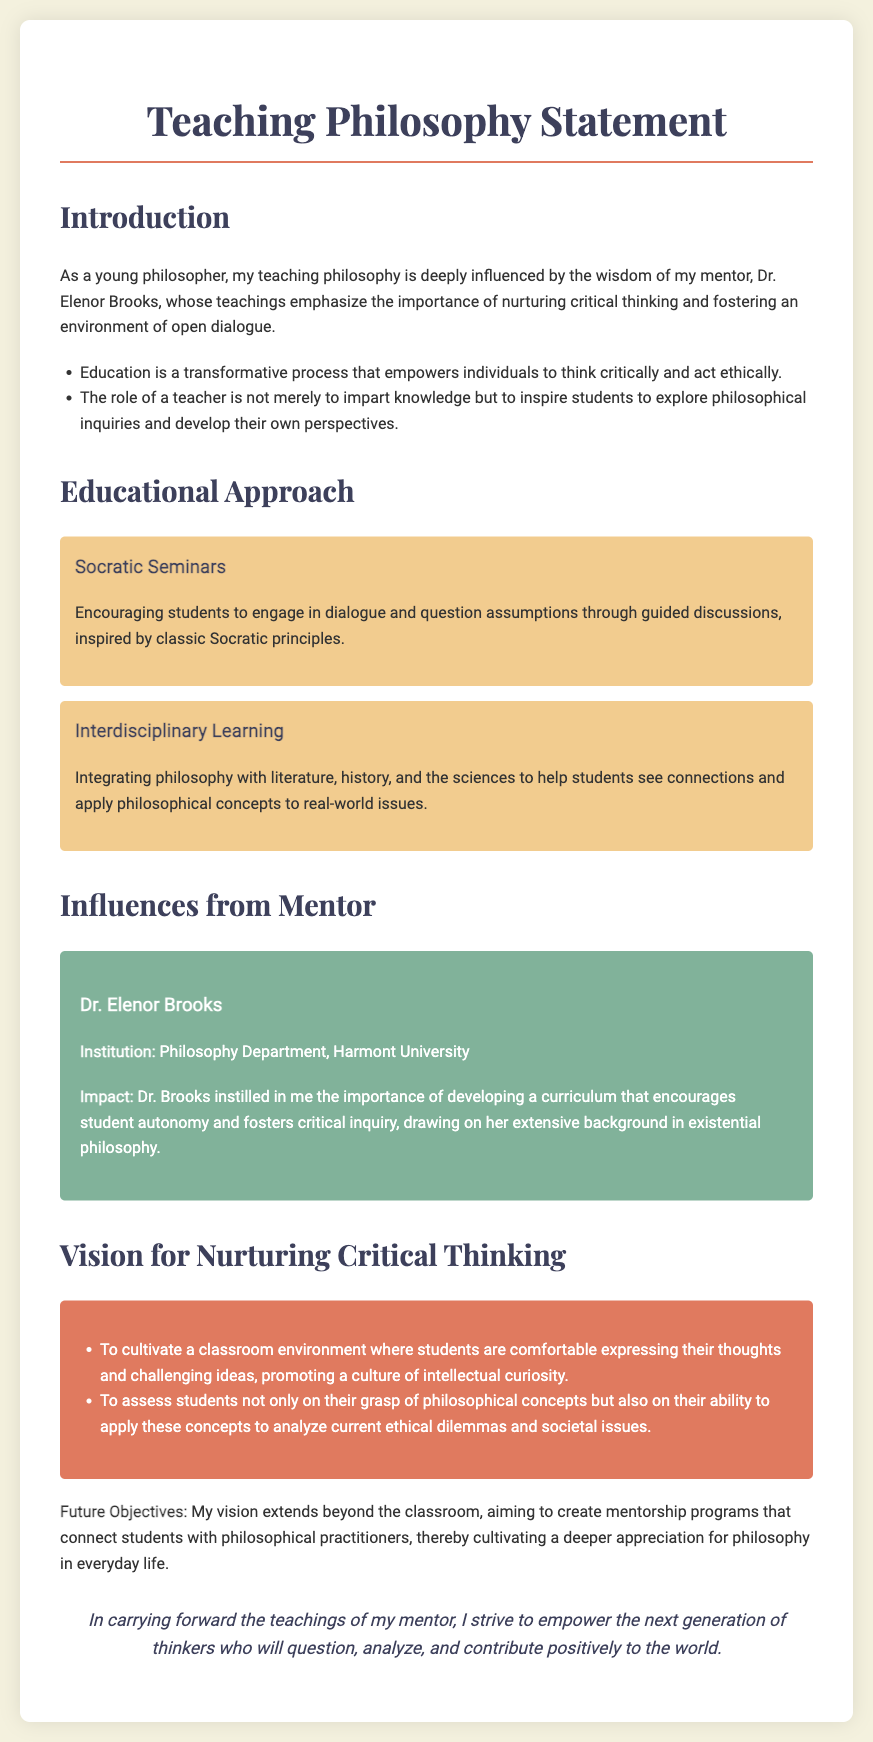What is the name of the mentor mentioned? The mentor mentioned is a significant influence in the teaching philosophy. The document states her name clearly as "Dr. Elenor Brooks."
Answer: Dr. Elenor Brooks What is the institution where the mentor teaches? The document specifies the mentor's affiliation, indicating her institutional background.
Answer: Harmont University What educational approach is highlighted first in the document? The first method of teaching outlined in the document is about a classical technique often used for discussion-based learning.
Answer: Socratic Seminars What are the two areas integrated into the educational approach besides philosophy? The document explains an interdisciplinary approach that connects philosophy with other fields, specifying two.
Answer: Literature and history What key concept does the teaching philosophy emphasize regarding students' expression? The document highlights the importance of creating an environment where students can share their thoughts freely.
Answer: Intellectual curiosity How does the teaching philosophy propose to assess students? The assessment approach outlined in the document goes beyond just knowledge retention to a more practical application of learned concepts.
Answer: Analyze current ethical dilemmas What is one future objective mentioned for nurturing critical thinking? The document outlines an ambition beyond immediate teaching practices, focusing on mentorship programs as part of future goals.
Answer: Create mentorship programs What is the background of the mentor in the teaching philosophy? The document provides insight into the mentor's expertise, specifically focusing on a philosophical specialty that shapes her teachings.
Answer: Existential philosophy 